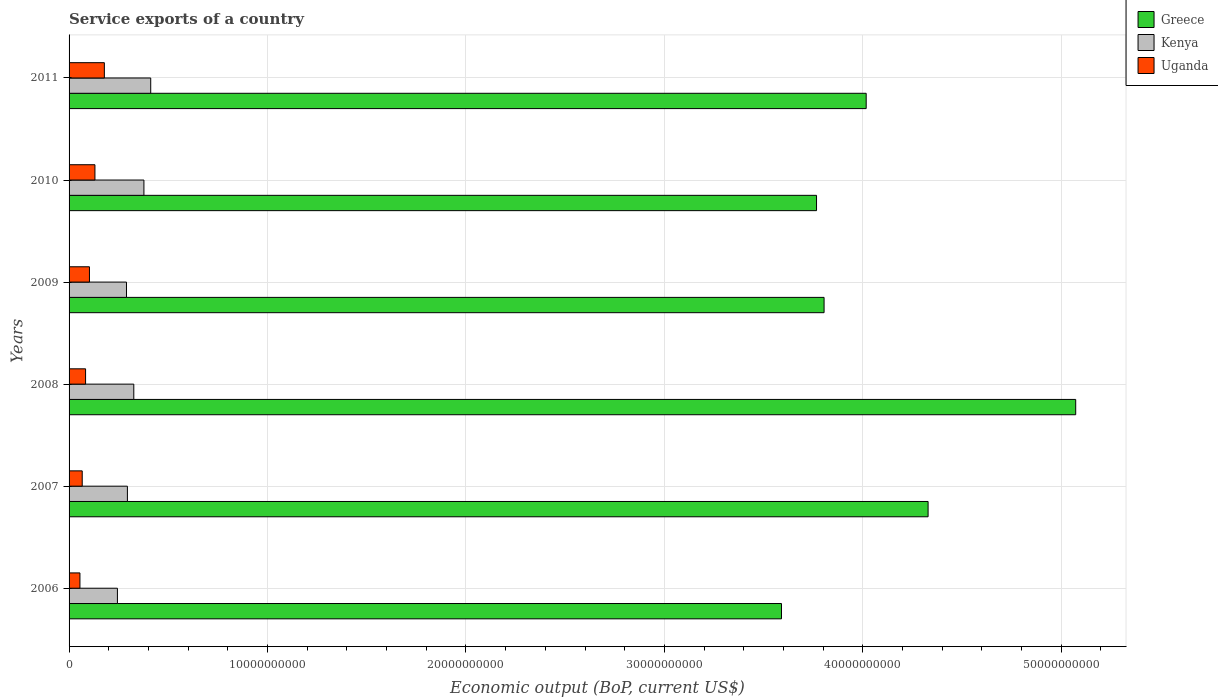How many different coloured bars are there?
Offer a very short reply. 3. Are the number of bars per tick equal to the number of legend labels?
Your answer should be very brief. Yes. Are the number of bars on each tick of the Y-axis equal?
Keep it short and to the point. Yes. What is the label of the 3rd group of bars from the top?
Give a very brief answer. 2009. What is the service exports in Greece in 2008?
Give a very brief answer. 5.07e+1. Across all years, what is the maximum service exports in Uganda?
Provide a short and direct response. 1.78e+09. Across all years, what is the minimum service exports in Uganda?
Make the answer very short. 5.48e+08. In which year was the service exports in Kenya minimum?
Offer a terse response. 2006. What is the total service exports in Kenya in the graph?
Provide a succinct answer. 1.94e+1. What is the difference between the service exports in Greece in 2007 and that in 2009?
Provide a short and direct response. 5.24e+09. What is the difference between the service exports in Kenya in 2008 and the service exports in Greece in 2007?
Offer a very short reply. -4.00e+1. What is the average service exports in Kenya per year?
Make the answer very short. 3.24e+09. In the year 2011, what is the difference between the service exports in Greece and service exports in Uganda?
Provide a succinct answer. 3.84e+1. What is the ratio of the service exports in Greece in 2006 to that in 2010?
Keep it short and to the point. 0.95. Is the service exports in Greece in 2007 less than that in 2011?
Your answer should be very brief. No. What is the difference between the highest and the second highest service exports in Greece?
Provide a succinct answer. 7.44e+09. What is the difference between the highest and the lowest service exports in Greece?
Offer a terse response. 1.48e+1. What does the 3rd bar from the bottom in 2006 represents?
Your response must be concise. Uganda. Is it the case that in every year, the sum of the service exports in Kenya and service exports in Uganda is greater than the service exports in Greece?
Make the answer very short. No. How many bars are there?
Keep it short and to the point. 18. What is the difference between two consecutive major ticks on the X-axis?
Your answer should be very brief. 1.00e+1. Are the values on the major ticks of X-axis written in scientific E-notation?
Ensure brevity in your answer.  No. Does the graph contain grids?
Ensure brevity in your answer.  Yes. What is the title of the graph?
Your answer should be very brief. Service exports of a country. What is the label or title of the X-axis?
Provide a succinct answer. Economic output (BoP, current US$). What is the Economic output (BoP, current US$) in Greece in 2006?
Ensure brevity in your answer.  3.59e+1. What is the Economic output (BoP, current US$) of Kenya in 2006?
Make the answer very short. 2.44e+09. What is the Economic output (BoP, current US$) of Uganda in 2006?
Offer a very short reply. 5.48e+08. What is the Economic output (BoP, current US$) of Greece in 2007?
Ensure brevity in your answer.  4.33e+1. What is the Economic output (BoP, current US$) of Kenya in 2007?
Keep it short and to the point. 2.94e+09. What is the Economic output (BoP, current US$) in Uganda in 2007?
Keep it short and to the point. 6.63e+08. What is the Economic output (BoP, current US$) in Greece in 2008?
Your response must be concise. 5.07e+1. What is the Economic output (BoP, current US$) in Kenya in 2008?
Ensure brevity in your answer.  3.26e+09. What is the Economic output (BoP, current US$) of Uganda in 2008?
Give a very brief answer. 8.32e+08. What is the Economic output (BoP, current US$) of Greece in 2009?
Offer a terse response. 3.80e+1. What is the Economic output (BoP, current US$) of Kenya in 2009?
Your answer should be compact. 2.89e+09. What is the Economic output (BoP, current US$) in Uganda in 2009?
Your answer should be compact. 1.03e+09. What is the Economic output (BoP, current US$) in Greece in 2010?
Give a very brief answer. 3.77e+1. What is the Economic output (BoP, current US$) of Kenya in 2010?
Keep it short and to the point. 3.77e+09. What is the Economic output (BoP, current US$) of Uganda in 2010?
Give a very brief answer. 1.30e+09. What is the Economic output (BoP, current US$) of Greece in 2011?
Your response must be concise. 4.02e+1. What is the Economic output (BoP, current US$) in Kenya in 2011?
Make the answer very short. 4.11e+09. What is the Economic output (BoP, current US$) of Uganda in 2011?
Your answer should be very brief. 1.78e+09. Across all years, what is the maximum Economic output (BoP, current US$) in Greece?
Your response must be concise. 5.07e+1. Across all years, what is the maximum Economic output (BoP, current US$) of Kenya?
Give a very brief answer. 4.11e+09. Across all years, what is the maximum Economic output (BoP, current US$) in Uganda?
Ensure brevity in your answer.  1.78e+09. Across all years, what is the minimum Economic output (BoP, current US$) in Greece?
Offer a very short reply. 3.59e+1. Across all years, what is the minimum Economic output (BoP, current US$) in Kenya?
Ensure brevity in your answer.  2.44e+09. Across all years, what is the minimum Economic output (BoP, current US$) in Uganda?
Keep it short and to the point. 5.48e+08. What is the total Economic output (BoP, current US$) of Greece in the graph?
Your response must be concise. 2.46e+11. What is the total Economic output (BoP, current US$) of Kenya in the graph?
Offer a terse response. 1.94e+1. What is the total Economic output (BoP, current US$) in Uganda in the graph?
Your answer should be very brief. 6.15e+09. What is the difference between the Economic output (BoP, current US$) in Greece in 2006 and that in 2007?
Offer a very short reply. -7.39e+09. What is the difference between the Economic output (BoP, current US$) of Kenya in 2006 and that in 2007?
Provide a succinct answer. -5.03e+08. What is the difference between the Economic output (BoP, current US$) in Uganda in 2006 and that in 2007?
Provide a succinct answer. -1.15e+08. What is the difference between the Economic output (BoP, current US$) in Greece in 2006 and that in 2008?
Ensure brevity in your answer.  -1.48e+1. What is the difference between the Economic output (BoP, current US$) in Kenya in 2006 and that in 2008?
Your answer should be compact. -8.25e+08. What is the difference between the Economic output (BoP, current US$) of Uganda in 2006 and that in 2008?
Give a very brief answer. -2.84e+08. What is the difference between the Economic output (BoP, current US$) of Greece in 2006 and that in 2009?
Keep it short and to the point. -2.15e+09. What is the difference between the Economic output (BoP, current US$) in Kenya in 2006 and that in 2009?
Your answer should be compact. -4.56e+08. What is the difference between the Economic output (BoP, current US$) in Uganda in 2006 and that in 2009?
Keep it short and to the point. -4.79e+08. What is the difference between the Economic output (BoP, current US$) of Greece in 2006 and that in 2010?
Your answer should be compact. -1.77e+09. What is the difference between the Economic output (BoP, current US$) in Kenya in 2006 and that in 2010?
Your answer should be compact. -1.34e+09. What is the difference between the Economic output (BoP, current US$) of Uganda in 2006 and that in 2010?
Offer a terse response. -7.56e+08. What is the difference between the Economic output (BoP, current US$) in Greece in 2006 and that in 2011?
Make the answer very short. -4.27e+09. What is the difference between the Economic output (BoP, current US$) of Kenya in 2006 and that in 2011?
Make the answer very short. -1.68e+09. What is the difference between the Economic output (BoP, current US$) of Uganda in 2006 and that in 2011?
Make the answer very short. -1.23e+09. What is the difference between the Economic output (BoP, current US$) in Greece in 2007 and that in 2008?
Give a very brief answer. -7.44e+09. What is the difference between the Economic output (BoP, current US$) of Kenya in 2007 and that in 2008?
Give a very brief answer. -3.22e+08. What is the difference between the Economic output (BoP, current US$) of Uganda in 2007 and that in 2008?
Keep it short and to the point. -1.69e+08. What is the difference between the Economic output (BoP, current US$) of Greece in 2007 and that in 2009?
Give a very brief answer. 5.24e+09. What is the difference between the Economic output (BoP, current US$) of Kenya in 2007 and that in 2009?
Your response must be concise. 4.66e+07. What is the difference between the Economic output (BoP, current US$) in Uganda in 2007 and that in 2009?
Offer a very short reply. -3.64e+08. What is the difference between the Economic output (BoP, current US$) in Greece in 2007 and that in 2010?
Give a very brief answer. 5.62e+09. What is the difference between the Economic output (BoP, current US$) of Kenya in 2007 and that in 2010?
Provide a succinct answer. -8.33e+08. What is the difference between the Economic output (BoP, current US$) in Uganda in 2007 and that in 2010?
Make the answer very short. -6.41e+08. What is the difference between the Economic output (BoP, current US$) in Greece in 2007 and that in 2011?
Ensure brevity in your answer.  3.12e+09. What is the difference between the Economic output (BoP, current US$) in Kenya in 2007 and that in 2011?
Provide a short and direct response. -1.17e+09. What is the difference between the Economic output (BoP, current US$) in Uganda in 2007 and that in 2011?
Your response must be concise. -1.12e+09. What is the difference between the Economic output (BoP, current US$) of Greece in 2008 and that in 2009?
Offer a very short reply. 1.27e+1. What is the difference between the Economic output (BoP, current US$) in Kenya in 2008 and that in 2009?
Your answer should be compact. 3.69e+08. What is the difference between the Economic output (BoP, current US$) in Uganda in 2008 and that in 2009?
Ensure brevity in your answer.  -1.95e+08. What is the difference between the Economic output (BoP, current US$) of Greece in 2008 and that in 2010?
Your answer should be compact. 1.31e+1. What is the difference between the Economic output (BoP, current US$) in Kenya in 2008 and that in 2010?
Your answer should be compact. -5.10e+08. What is the difference between the Economic output (BoP, current US$) of Uganda in 2008 and that in 2010?
Your answer should be very brief. -4.72e+08. What is the difference between the Economic output (BoP, current US$) in Greece in 2008 and that in 2011?
Keep it short and to the point. 1.06e+1. What is the difference between the Economic output (BoP, current US$) in Kenya in 2008 and that in 2011?
Offer a very short reply. -8.53e+08. What is the difference between the Economic output (BoP, current US$) of Uganda in 2008 and that in 2011?
Your response must be concise. -9.46e+08. What is the difference between the Economic output (BoP, current US$) in Greece in 2009 and that in 2010?
Offer a very short reply. 3.80e+08. What is the difference between the Economic output (BoP, current US$) in Kenya in 2009 and that in 2010?
Ensure brevity in your answer.  -8.79e+08. What is the difference between the Economic output (BoP, current US$) in Uganda in 2009 and that in 2010?
Offer a terse response. -2.76e+08. What is the difference between the Economic output (BoP, current US$) of Greece in 2009 and that in 2011?
Make the answer very short. -2.12e+09. What is the difference between the Economic output (BoP, current US$) of Kenya in 2009 and that in 2011?
Ensure brevity in your answer.  -1.22e+09. What is the difference between the Economic output (BoP, current US$) of Uganda in 2009 and that in 2011?
Offer a terse response. -7.51e+08. What is the difference between the Economic output (BoP, current US$) of Greece in 2010 and that in 2011?
Offer a terse response. -2.50e+09. What is the difference between the Economic output (BoP, current US$) of Kenya in 2010 and that in 2011?
Make the answer very short. -3.42e+08. What is the difference between the Economic output (BoP, current US$) of Uganda in 2010 and that in 2011?
Your response must be concise. -4.75e+08. What is the difference between the Economic output (BoP, current US$) in Greece in 2006 and the Economic output (BoP, current US$) in Kenya in 2007?
Provide a succinct answer. 3.30e+1. What is the difference between the Economic output (BoP, current US$) in Greece in 2006 and the Economic output (BoP, current US$) in Uganda in 2007?
Your answer should be very brief. 3.52e+1. What is the difference between the Economic output (BoP, current US$) in Kenya in 2006 and the Economic output (BoP, current US$) in Uganda in 2007?
Give a very brief answer. 1.77e+09. What is the difference between the Economic output (BoP, current US$) in Greece in 2006 and the Economic output (BoP, current US$) in Kenya in 2008?
Your response must be concise. 3.26e+1. What is the difference between the Economic output (BoP, current US$) in Greece in 2006 and the Economic output (BoP, current US$) in Uganda in 2008?
Make the answer very short. 3.51e+1. What is the difference between the Economic output (BoP, current US$) in Kenya in 2006 and the Economic output (BoP, current US$) in Uganda in 2008?
Provide a short and direct response. 1.60e+09. What is the difference between the Economic output (BoP, current US$) in Greece in 2006 and the Economic output (BoP, current US$) in Kenya in 2009?
Give a very brief answer. 3.30e+1. What is the difference between the Economic output (BoP, current US$) of Greece in 2006 and the Economic output (BoP, current US$) of Uganda in 2009?
Ensure brevity in your answer.  3.49e+1. What is the difference between the Economic output (BoP, current US$) in Kenya in 2006 and the Economic output (BoP, current US$) in Uganda in 2009?
Keep it short and to the point. 1.41e+09. What is the difference between the Economic output (BoP, current US$) in Greece in 2006 and the Economic output (BoP, current US$) in Kenya in 2010?
Offer a terse response. 3.21e+1. What is the difference between the Economic output (BoP, current US$) in Greece in 2006 and the Economic output (BoP, current US$) in Uganda in 2010?
Your answer should be compact. 3.46e+1. What is the difference between the Economic output (BoP, current US$) in Kenya in 2006 and the Economic output (BoP, current US$) in Uganda in 2010?
Ensure brevity in your answer.  1.13e+09. What is the difference between the Economic output (BoP, current US$) of Greece in 2006 and the Economic output (BoP, current US$) of Kenya in 2011?
Give a very brief answer. 3.18e+1. What is the difference between the Economic output (BoP, current US$) of Greece in 2006 and the Economic output (BoP, current US$) of Uganda in 2011?
Offer a very short reply. 3.41e+1. What is the difference between the Economic output (BoP, current US$) in Kenya in 2006 and the Economic output (BoP, current US$) in Uganda in 2011?
Provide a succinct answer. 6.58e+08. What is the difference between the Economic output (BoP, current US$) of Greece in 2007 and the Economic output (BoP, current US$) of Kenya in 2008?
Your answer should be very brief. 4.00e+1. What is the difference between the Economic output (BoP, current US$) of Greece in 2007 and the Economic output (BoP, current US$) of Uganda in 2008?
Keep it short and to the point. 4.25e+1. What is the difference between the Economic output (BoP, current US$) in Kenya in 2007 and the Economic output (BoP, current US$) in Uganda in 2008?
Give a very brief answer. 2.11e+09. What is the difference between the Economic output (BoP, current US$) of Greece in 2007 and the Economic output (BoP, current US$) of Kenya in 2009?
Your answer should be compact. 4.04e+1. What is the difference between the Economic output (BoP, current US$) in Greece in 2007 and the Economic output (BoP, current US$) in Uganda in 2009?
Ensure brevity in your answer.  4.23e+1. What is the difference between the Economic output (BoP, current US$) in Kenya in 2007 and the Economic output (BoP, current US$) in Uganda in 2009?
Offer a terse response. 1.91e+09. What is the difference between the Economic output (BoP, current US$) in Greece in 2007 and the Economic output (BoP, current US$) in Kenya in 2010?
Your answer should be very brief. 3.95e+1. What is the difference between the Economic output (BoP, current US$) in Greece in 2007 and the Economic output (BoP, current US$) in Uganda in 2010?
Your response must be concise. 4.20e+1. What is the difference between the Economic output (BoP, current US$) in Kenya in 2007 and the Economic output (BoP, current US$) in Uganda in 2010?
Provide a succinct answer. 1.64e+09. What is the difference between the Economic output (BoP, current US$) in Greece in 2007 and the Economic output (BoP, current US$) in Kenya in 2011?
Keep it short and to the point. 3.92e+1. What is the difference between the Economic output (BoP, current US$) of Greece in 2007 and the Economic output (BoP, current US$) of Uganda in 2011?
Make the answer very short. 4.15e+1. What is the difference between the Economic output (BoP, current US$) of Kenya in 2007 and the Economic output (BoP, current US$) of Uganda in 2011?
Give a very brief answer. 1.16e+09. What is the difference between the Economic output (BoP, current US$) of Greece in 2008 and the Economic output (BoP, current US$) of Kenya in 2009?
Your response must be concise. 4.78e+1. What is the difference between the Economic output (BoP, current US$) of Greece in 2008 and the Economic output (BoP, current US$) of Uganda in 2009?
Ensure brevity in your answer.  4.97e+1. What is the difference between the Economic output (BoP, current US$) of Kenya in 2008 and the Economic output (BoP, current US$) of Uganda in 2009?
Provide a succinct answer. 2.23e+09. What is the difference between the Economic output (BoP, current US$) of Greece in 2008 and the Economic output (BoP, current US$) of Kenya in 2010?
Provide a short and direct response. 4.70e+1. What is the difference between the Economic output (BoP, current US$) in Greece in 2008 and the Economic output (BoP, current US$) in Uganda in 2010?
Provide a short and direct response. 4.94e+1. What is the difference between the Economic output (BoP, current US$) of Kenya in 2008 and the Economic output (BoP, current US$) of Uganda in 2010?
Make the answer very short. 1.96e+09. What is the difference between the Economic output (BoP, current US$) in Greece in 2008 and the Economic output (BoP, current US$) in Kenya in 2011?
Ensure brevity in your answer.  4.66e+1. What is the difference between the Economic output (BoP, current US$) of Greece in 2008 and the Economic output (BoP, current US$) of Uganda in 2011?
Your response must be concise. 4.89e+1. What is the difference between the Economic output (BoP, current US$) of Kenya in 2008 and the Economic output (BoP, current US$) of Uganda in 2011?
Give a very brief answer. 1.48e+09. What is the difference between the Economic output (BoP, current US$) in Greece in 2009 and the Economic output (BoP, current US$) in Kenya in 2010?
Your answer should be compact. 3.43e+1. What is the difference between the Economic output (BoP, current US$) in Greece in 2009 and the Economic output (BoP, current US$) in Uganda in 2010?
Your answer should be compact. 3.67e+1. What is the difference between the Economic output (BoP, current US$) in Kenya in 2009 and the Economic output (BoP, current US$) in Uganda in 2010?
Your answer should be compact. 1.59e+09. What is the difference between the Economic output (BoP, current US$) of Greece in 2009 and the Economic output (BoP, current US$) of Kenya in 2011?
Your answer should be very brief. 3.39e+1. What is the difference between the Economic output (BoP, current US$) in Greece in 2009 and the Economic output (BoP, current US$) in Uganda in 2011?
Give a very brief answer. 3.63e+1. What is the difference between the Economic output (BoP, current US$) of Kenya in 2009 and the Economic output (BoP, current US$) of Uganda in 2011?
Your answer should be very brief. 1.11e+09. What is the difference between the Economic output (BoP, current US$) in Greece in 2010 and the Economic output (BoP, current US$) in Kenya in 2011?
Ensure brevity in your answer.  3.36e+1. What is the difference between the Economic output (BoP, current US$) in Greece in 2010 and the Economic output (BoP, current US$) in Uganda in 2011?
Give a very brief answer. 3.59e+1. What is the difference between the Economic output (BoP, current US$) of Kenya in 2010 and the Economic output (BoP, current US$) of Uganda in 2011?
Offer a terse response. 1.99e+09. What is the average Economic output (BoP, current US$) in Greece per year?
Make the answer very short. 4.10e+1. What is the average Economic output (BoP, current US$) of Kenya per year?
Give a very brief answer. 3.24e+09. What is the average Economic output (BoP, current US$) in Uganda per year?
Offer a very short reply. 1.03e+09. In the year 2006, what is the difference between the Economic output (BoP, current US$) in Greece and Economic output (BoP, current US$) in Kenya?
Ensure brevity in your answer.  3.35e+1. In the year 2006, what is the difference between the Economic output (BoP, current US$) of Greece and Economic output (BoP, current US$) of Uganda?
Provide a succinct answer. 3.54e+1. In the year 2006, what is the difference between the Economic output (BoP, current US$) in Kenya and Economic output (BoP, current US$) in Uganda?
Provide a short and direct response. 1.89e+09. In the year 2007, what is the difference between the Economic output (BoP, current US$) of Greece and Economic output (BoP, current US$) of Kenya?
Keep it short and to the point. 4.03e+1. In the year 2007, what is the difference between the Economic output (BoP, current US$) in Greece and Economic output (BoP, current US$) in Uganda?
Offer a terse response. 4.26e+1. In the year 2007, what is the difference between the Economic output (BoP, current US$) in Kenya and Economic output (BoP, current US$) in Uganda?
Your response must be concise. 2.28e+09. In the year 2008, what is the difference between the Economic output (BoP, current US$) in Greece and Economic output (BoP, current US$) in Kenya?
Provide a short and direct response. 4.75e+1. In the year 2008, what is the difference between the Economic output (BoP, current US$) of Greece and Economic output (BoP, current US$) of Uganda?
Ensure brevity in your answer.  4.99e+1. In the year 2008, what is the difference between the Economic output (BoP, current US$) in Kenya and Economic output (BoP, current US$) in Uganda?
Make the answer very short. 2.43e+09. In the year 2009, what is the difference between the Economic output (BoP, current US$) of Greece and Economic output (BoP, current US$) of Kenya?
Offer a terse response. 3.52e+1. In the year 2009, what is the difference between the Economic output (BoP, current US$) in Greece and Economic output (BoP, current US$) in Uganda?
Keep it short and to the point. 3.70e+1. In the year 2009, what is the difference between the Economic output (BoP, current US$) in Kenya and Economic output (BoP, current US$) in Uganda?
Your answer should be very brief. 1.87e+09. In the year 2010, what is the difference between the Economic output (BoP, current US$) in Greece and Economic output (BoP, current US$) in Kenya?
Your answer should be very brief. 3.39e+1. In the year 2010, what is the difference between the Economic output (BoP, current US$) in Greece and Economic output (BoP, current US$) in Uganda?
Provide a short and direct response. 3.64e+1. In the year 2010, what is the difference between the Economic output (BoP, current US$) in Kenya and Economic output (BoP, current US$) in Uganda?
Your response must be concise. 2.47e+09. In the year 2011, what is the difference between the Economic output (BoP, current US$) of Greece and Economic output (BoP, current US$) of Kenya?
Offer a very short reply. 3.61e+1. In the year 2011, what is the difference between the Economic output (BoP, current US$) in Greece and Economic output (BoP, current US$) in Uganda?
Provide a short and direct response. 3.84e+1. In the year 2011, what is the difference between the Economic output (BoP, current US$) of Kenya and Economic output (BoP, current US$) of Uganda?
Give a very brief answer. 2.34e+09. What is the ratio of the Economic output (BoP, current US$) in Greece in 2006 to that in 2007?
Your response must be concise. 0.83. What is the ratio of the Economic output (BoP, current US$) in Kenya in 2006 to that in 2007?
Ensure brevity in your answer.  0.83. What is the ratio of the Economic output (BoP, current US$) of Uganda in 2006 to that in 2007?
Provide a short and direct response. 0.83. What is the ratio of the Economic output (BoP, current US$) in Greece in 2006 to that in 2008?
Offer a very short reply. 0.71. What is the ratio of the Economic output (BoP, current US$) of Kenya in 2006 to that in 2008?
Your response must be concise. 0.75. What is the ratio of the Economic output (BoP, current US$) in Uganda in 2006 to that in 2008?
Keep it short and to the point. 0.66. What is the ratio of the Economic output (BoP, current US$) of Greece in 2006 to that in 2009?
Provide a succinct answer. 0.94. What is the ratio of the Economic output (BoP, current US$) of Kenya in 2006 to that in 2009?
Ensure brevity in your answer.  0.84. What is the ratio of the Economic output (BoP, current US$) in Uganda in 2006 to that in 2009?
Your response must be concise. 0.53. What is the ratio of the Economic output (BoP, current US$) of Greece in 2006 to that in 2010?
Give a very brief answer. 0.95. What is the ratio of the Economic output (BoP, current US$) in Kenya in 2006 to that in 2010?
Give a very brief answer. 0.65. What is the ratio of the Economic output (BoP, current US$) in Uganda in 2006 to that in 2010?
Your response must be concise. 0.42. What is the ratio of the Economic output (BoP, current US$) of Greece in 2006 to that in 2011?
Provide a succinct answer. 0.89. What is the ratio of the Economic output (BoP, current US$) in Kenya in 2006 to that in 2011?
Your answer should be compact. 0.59. What is the ratio of the Economic output (BoP, current US$) in Uganda in 2006 to that in 2011?
Your answer should be compact. 0.31. What is the ratio of the Economic output (BoP, current US$) of Greece in 2007 to that in 2008?
Provide a succinct answer. 0.85. What is the ratio of the Economic output (BoP, current US$) of Kenya in 2007 to that in 2008?
Your answer should be compact. 0.9. What is the ratio of the Economic output (BoP, current US$) of Uganda in 2007 to that in 2008?
Ensure brevity in your answer.  0.8. What is the ratio of the Economic output (BoP, current US$) in Greece in 2007 to that in 2009?
Ensure brevity in your answer.  1.14. What is the ratio of the Economic output (BoP, current US$) of Kenya in 2007 to that in 2009?
Provide a short and direct response. 1.02. What is the ratio of the Economic output (BoP, current US$) in Uganda in 2007 to that in 2009?
Provide a short and direct response. 0.65. What is the ratio of the Economic output (BoP, current US$) of Greece in 2007 to that in 2010?
Give a very brief answer. 1.15. What is the ratio of the Economic output (BoP, current US$) in Kenya in 2007 to that in 2010?
Ensure brevity in your answer.  0.78. What is the ratio of the Economic output (BoP, current US$) in Uganda in 2007 to that in 2010?
Your answer should be very brief. 0.51. What is the ratio of the Economic output (BoP, current US$) in Greece in 2007 to that in 2011?
Offer a very short reply. 1.08. What is the ratio of the Economic output (BoP, current US$) in Kenya in 2007 to that in 2011?
Ensure brevity in your answer.  0.71. What is the ratio of the Economic output (BoP, current US$) in Uganda in 2007 to that in 2011?
Provide a succinct answer. 0.37. What is the ratio of the Economic output (BoP, current US$) of Greece in 2008 to that in 2009?
Offer a terse response. 1.33. What is the ratio of the Economic output (BoP, current US$) in Kenya in 2008 to that in 2009?
Offer a very short reply. 1.13. What is the ratio of the Economic output (BoP, current US$) in Uganda in 2008 to that in 2009?
Your answer should be very brief. 0.81. What is the ratio of the Economic output (BoP, current US$) of Greece in 2008 to that in 2010?
Your answer should be very brief. 1.35. What is the ratio of the Economic output (BoP, current US$) in Kenya in 2008 to that in 2010?
Give a very brief answer. 0.86. What is the ratio of the Economic output (BoP, current US$) of Uganda in 2008 to that in 2010?
Ensure brevity in your answer.  0.64. What is the ratio of the Economic output (BoP, current US$) of Greece in 2008 to that in 2011?
Offer a terse response. 1.26. What is the ratio of the Economic output (BoP, current US$) of Kenya in 2008 to that in 2011?
Your response must be concise. 0.79. What is the ratio of the Economic output (BoP, current US$) in Uganda in 2008 to that in 2011?
Keep it short and to the point. 0.47. What is the ratio of the Economic output (BoP, current US$) of Kenya in 2009 to that in 2010?
Your answer should be compact. 0.77. What is the ratio of the Economic output (BoP, current US$) of Uganda in 2009 to that in 2010?
Keep it short and to the point. 0.79. What is the ratio of the Economic output (BoP, current US$) of Greece in 2009 to that in 2011?
Your answer should be compact. 0.95. What is the ratio of the Economic output (BoP, current US$) in Kenya in 2009 to that in 2011?
Your answer should be very brief. 0.7. What is the ratio of the Economic output (BoP, current US$) of Uganda in 2009 to that in 2011?
Make the answer very short. 0.58. What is the ratio of the Economic output (BoP, current US$) of Greece in 2010 to that in 2011?
Offer a very short reply. 0.94. What is the ratio of the Economic output (BoP, current US$) in Kenya in 2010 to that in 2011?
Offer a very short reply. 0.92. What is the ratio of the Economic output (BoP, current US$) in Uganda in 2010 to that in 2011?
Your response must be concise. 0.73. What is the difference between the highest and the second highest Economic output (BoP, current US$) in Greece?
Your answer should be compact. 7.44e+09. What is the difference between the highest and the second highest Economic output (BoP, current US$) of Kenya?
Offer a terse response. 3.42e+08. What is the difference between the highest and the second highest Economic output (BoP, current US$) of Uganda?
Provide a short and direct response. 4.75e+08. What is the difference between the highest and the lowest Economic output (BoP, current US$) of Greece?
Give a very brief answer. 1.48e+1. What is the difference between the highest and the lowest Economic output (BoP, current US$) of Kenya?
Provide a succinct answer. 1.68e+09. What is the difference between the highest and the lowest Economic output (BoP, current US$) of Uganda?
Your answer should be very brief. 1.23e+09. 